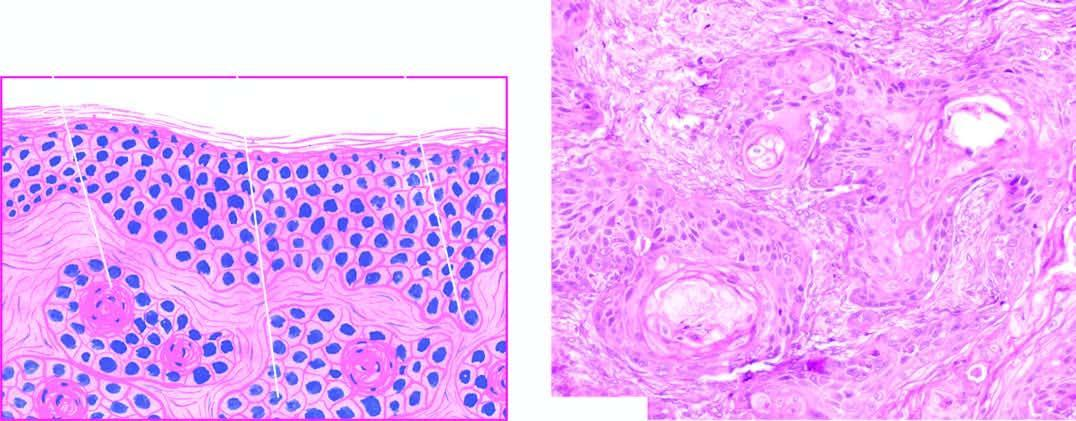what is the dermis invaded by?
Answer the question using a single word or phrase. Downward proliferating epidermal masses of cells 